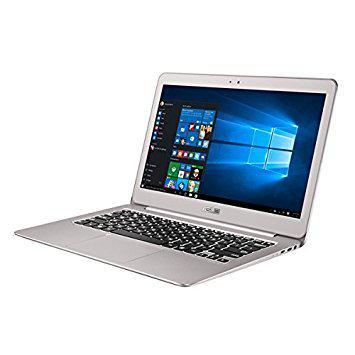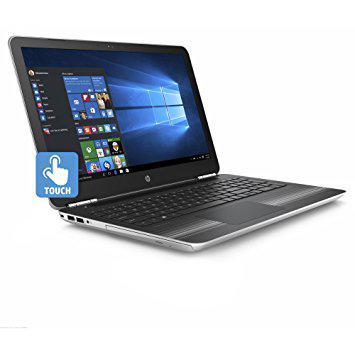The first image is the image on the left, the second image is the image on the right. Analyze the images presented: Is the assertion "The computer in the image on the left has a black casing." valid? Answer yes or no. No. The first image is the image on the left, the second image is the image on the right. Given the left and right images, does the statement "All laptops have the screen part attached to the keyboard base, and no laptop is displayed head-on." hold true? Answer yes or no. Yes. 